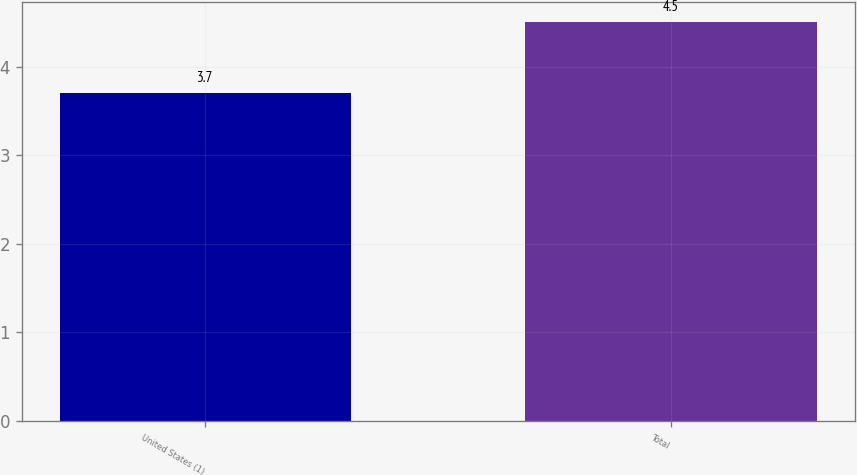Convert chart. <chart><loc_0><loc_0><loc_500><loc_500><bar_chart><fcel>United States (1)<fcel>Total<nl><fcel>3.7<fcel>4.5<nl></chart> 